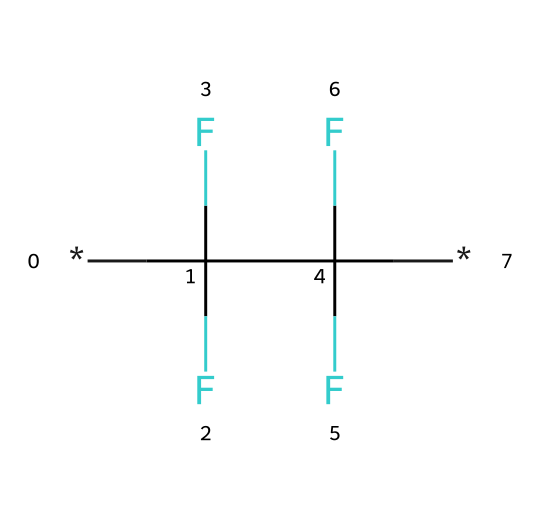What is the main component of the non-stick coating? The chemical represented by the SMILES is polytetrafluoroethylene (PTFE), which is known for its non-stick properties in coatings.
Answer: polytetrafluoroethylene How many carbon atoms are in the chemical structure? The SMILES contains a total of 2 carbon (C) atoms that are bonded to fluorine atoms, contributing to the structure of PTFE.
Answer: 2 What type of bonds are present in this chemical? The structure contains carbon-fluorine (C-F) bonds primarily, which are characteristic of fluoropolymers like PTFE, known for their strength and stability.
Answer: carbon-fluorine What is the total number of fluorine atoms in this molecule? Counting the fluorine (F) atoms represented in the SMILES, there are four fluorine atoms bonded to the carbon atoms, which is typical for PTFE.
Answer: 4 What property does the fluorine contribute to the lubricant? The fluorine atoms provide hydrophobicity to the chemical, making it non-reactive and giving it excellent lubricant properties, which is essential for a non-stick surface.
Answer: hydrophobicity Why is PTFE considered a good lubricant? PTFE's molecular structure, with its strong carbon-fluorine bonds and non-stick nature, allows it to reduce friction and wear on surfaces, making it an excellent lubricant in various applications.
Answer: reduces friction 